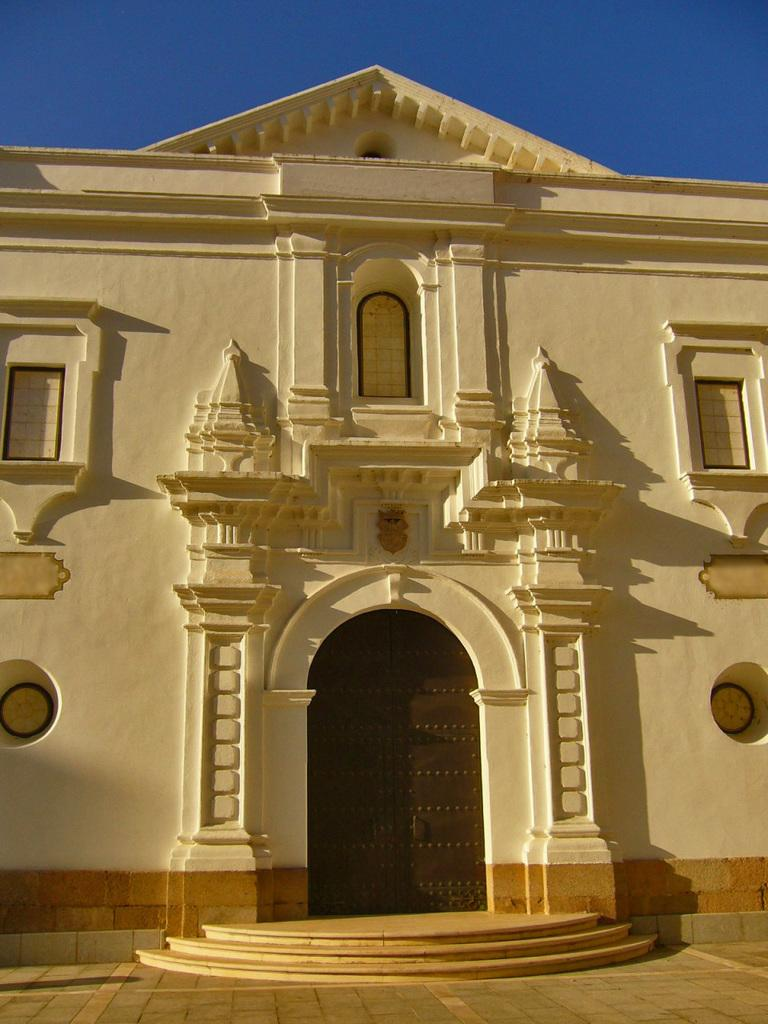What type of structure is present in the image? There is a building in the image. What can be seen beneath the building? The ground is visible in the image. What is visible above the building? The sky is visible in the image. How can someone access the building from the ground? There are stairs in the image that provide access to the building. What caption is written on the building in the image? There is no caption visible on the building in the image. Who is the owner of the bubble in the image? There is no bubble present in the image, so it is not possible to determine the owner. 